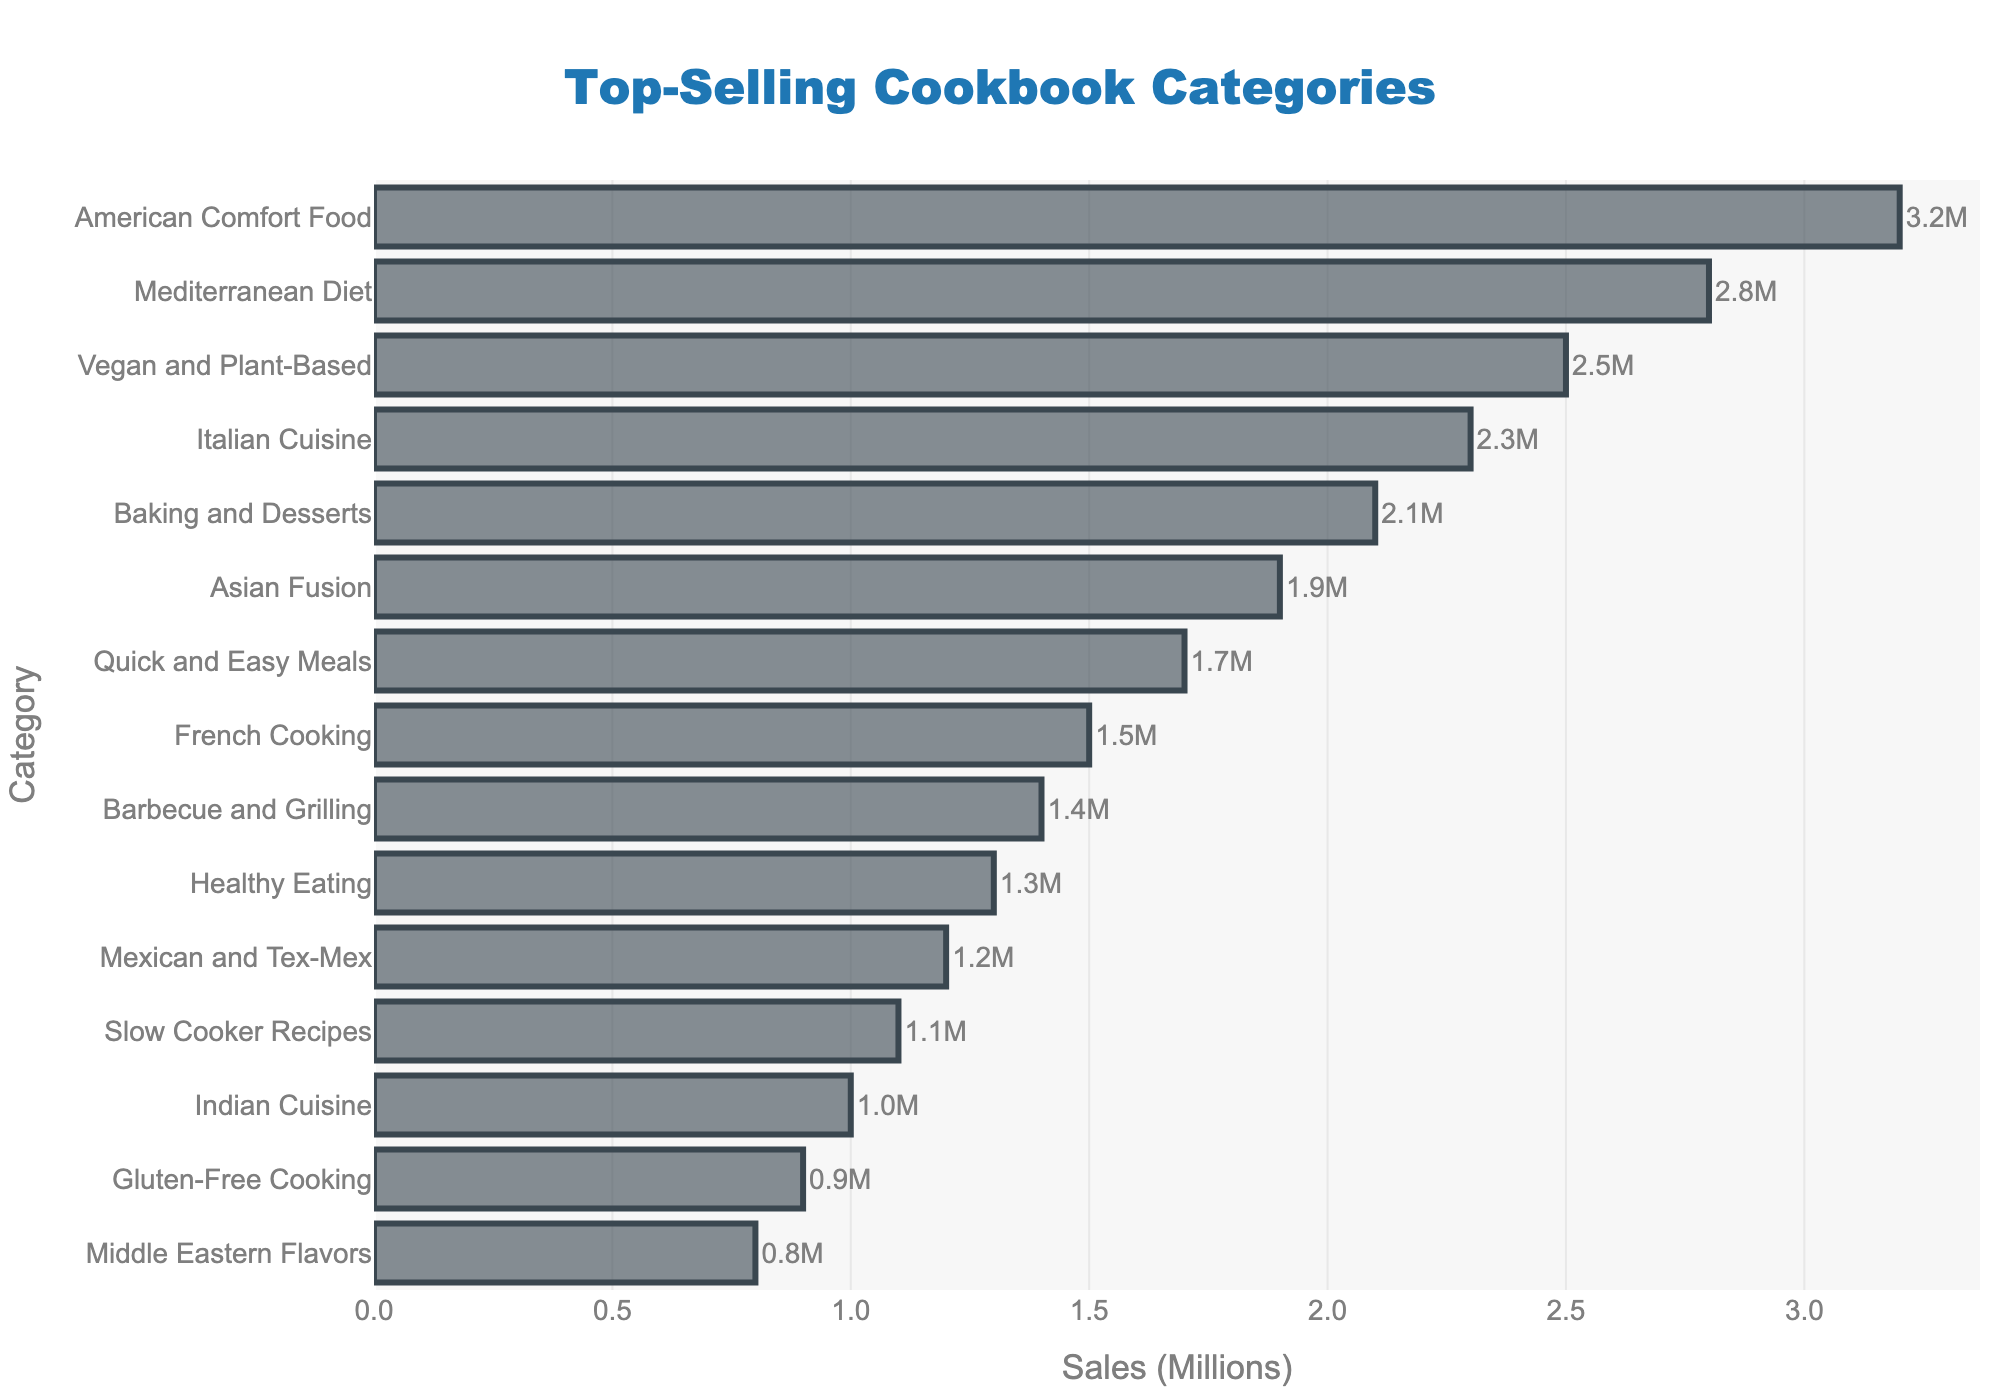Which cookbook category has the highest sales? The highest bar on the chart represents the cookbook category with the highest sales. Looking at the top of the chart, the category with the highest sales is "American Comfort Food," which is at the top right corner with the highest sales value.
Answer: American Comfort Food What is the sales difference between American Comfort Food and Mediterranean Diet cookbooks? The sales of American Comfort Food cookbooks are 3.2 million, and the sales of Mediterranean Diet cookbooks are 2.8 million. The difference is calculated as 3.2 - 2.8 = 0.4 million.
Answer: 0.4 million Which three categories have the lowest sales? The lowest bars on the chart represent the categories with the lowest sales. These categories are at the bottom of the y-axis. They are "Gluten-Free Cooking" with 0.9 million, "Middle Eastern Flavors" with 0.8 million, and "Indian Cuisine" with 1.0 million sales.
Answer: Gluten-Free Cooking, Middle Eastern Flavors, Indian Cuisine What is the average sales of the three top-selling cookbook categories? The top three categories are "American Comfort Food" with 3.2 million, "Mediterranean Diet" with 2.8 million, and "Vegan and Plant-Based" with 2.5 million. To find the average: (3.2 + 2.8 + 2.5) / 3 = 8.5 / 3 ≈ 2.83 million.
Answer: 2.83 million How many categories have sales greater than 2 million? To answer this, count the number of bars extending beyond the 2 million mark on the x-axis. These categories are "American Comfort Food," "Mediterranean Diet," "Vegan and Plant-Based," "Italian Cuisine," and "Baking and Desserts." There are 5 such categories.
Answer: 5 Which category has higher sales: Quick and Easy Meals or Barbecue and Grilling? The chart shows the sales for "Quick and Easy Meals" at 1.7 million and "Barbecue and Grilling" at 1.4 million. Since 1.7 is greater than 1.4, "Quick and Easy Meals" has higher sales.
Answer: Quick and Easy Meals What is the total sales of French Cooking and Asian Fusion cookbooks combined? The sales of French Cooking cookbooks are 1.5 million, and the sales of Asian Fusion cookbooks are 1.9 million. Adding them together: 1.5 + 1.9 = 3.4 million.
Answer: 3.4 million Which category's bar is directly above Italian Cuisine in the chart? Looking at the bar above Italian Cuisine (2.3 million), we see that "Vegan and Plant-Based" (2.5 million) is positioned directly above it on the y-axis.
Answer: Vegan and Plant-Based 